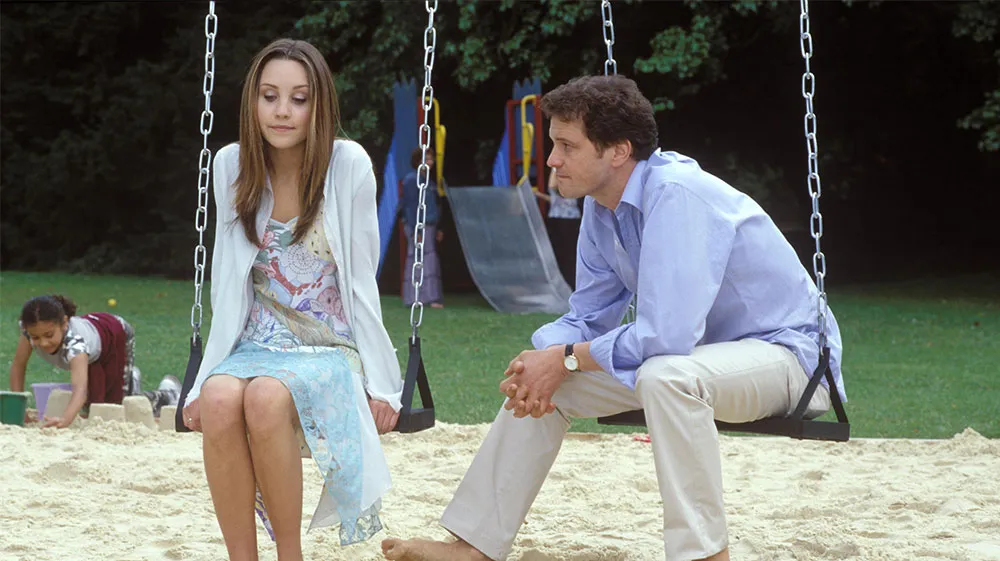Explain the visual content of the image in great detail. The image features two adults, a man and a woman, seated on swings in a sandbox at a public park. The man is dressed in a light blue button-up shirt and khaki pants, his posture relaxed as he gazes towards the woman with an attentive look. The woman, wearing a blue and white floral dress with a light sweater, sits facing him, her expression thoughtful and slightly reserved. The background shows a vibrant playground setting with various children engaged in play, highlighting a contrast between the calm, introspective interaction of the adults and the lively energy of the children around them. This scene might symbolize a moment of adult reflection amid the chaos of youthful energy or suggest a narrative of reconnecting in a nostalgic, familiar space. 